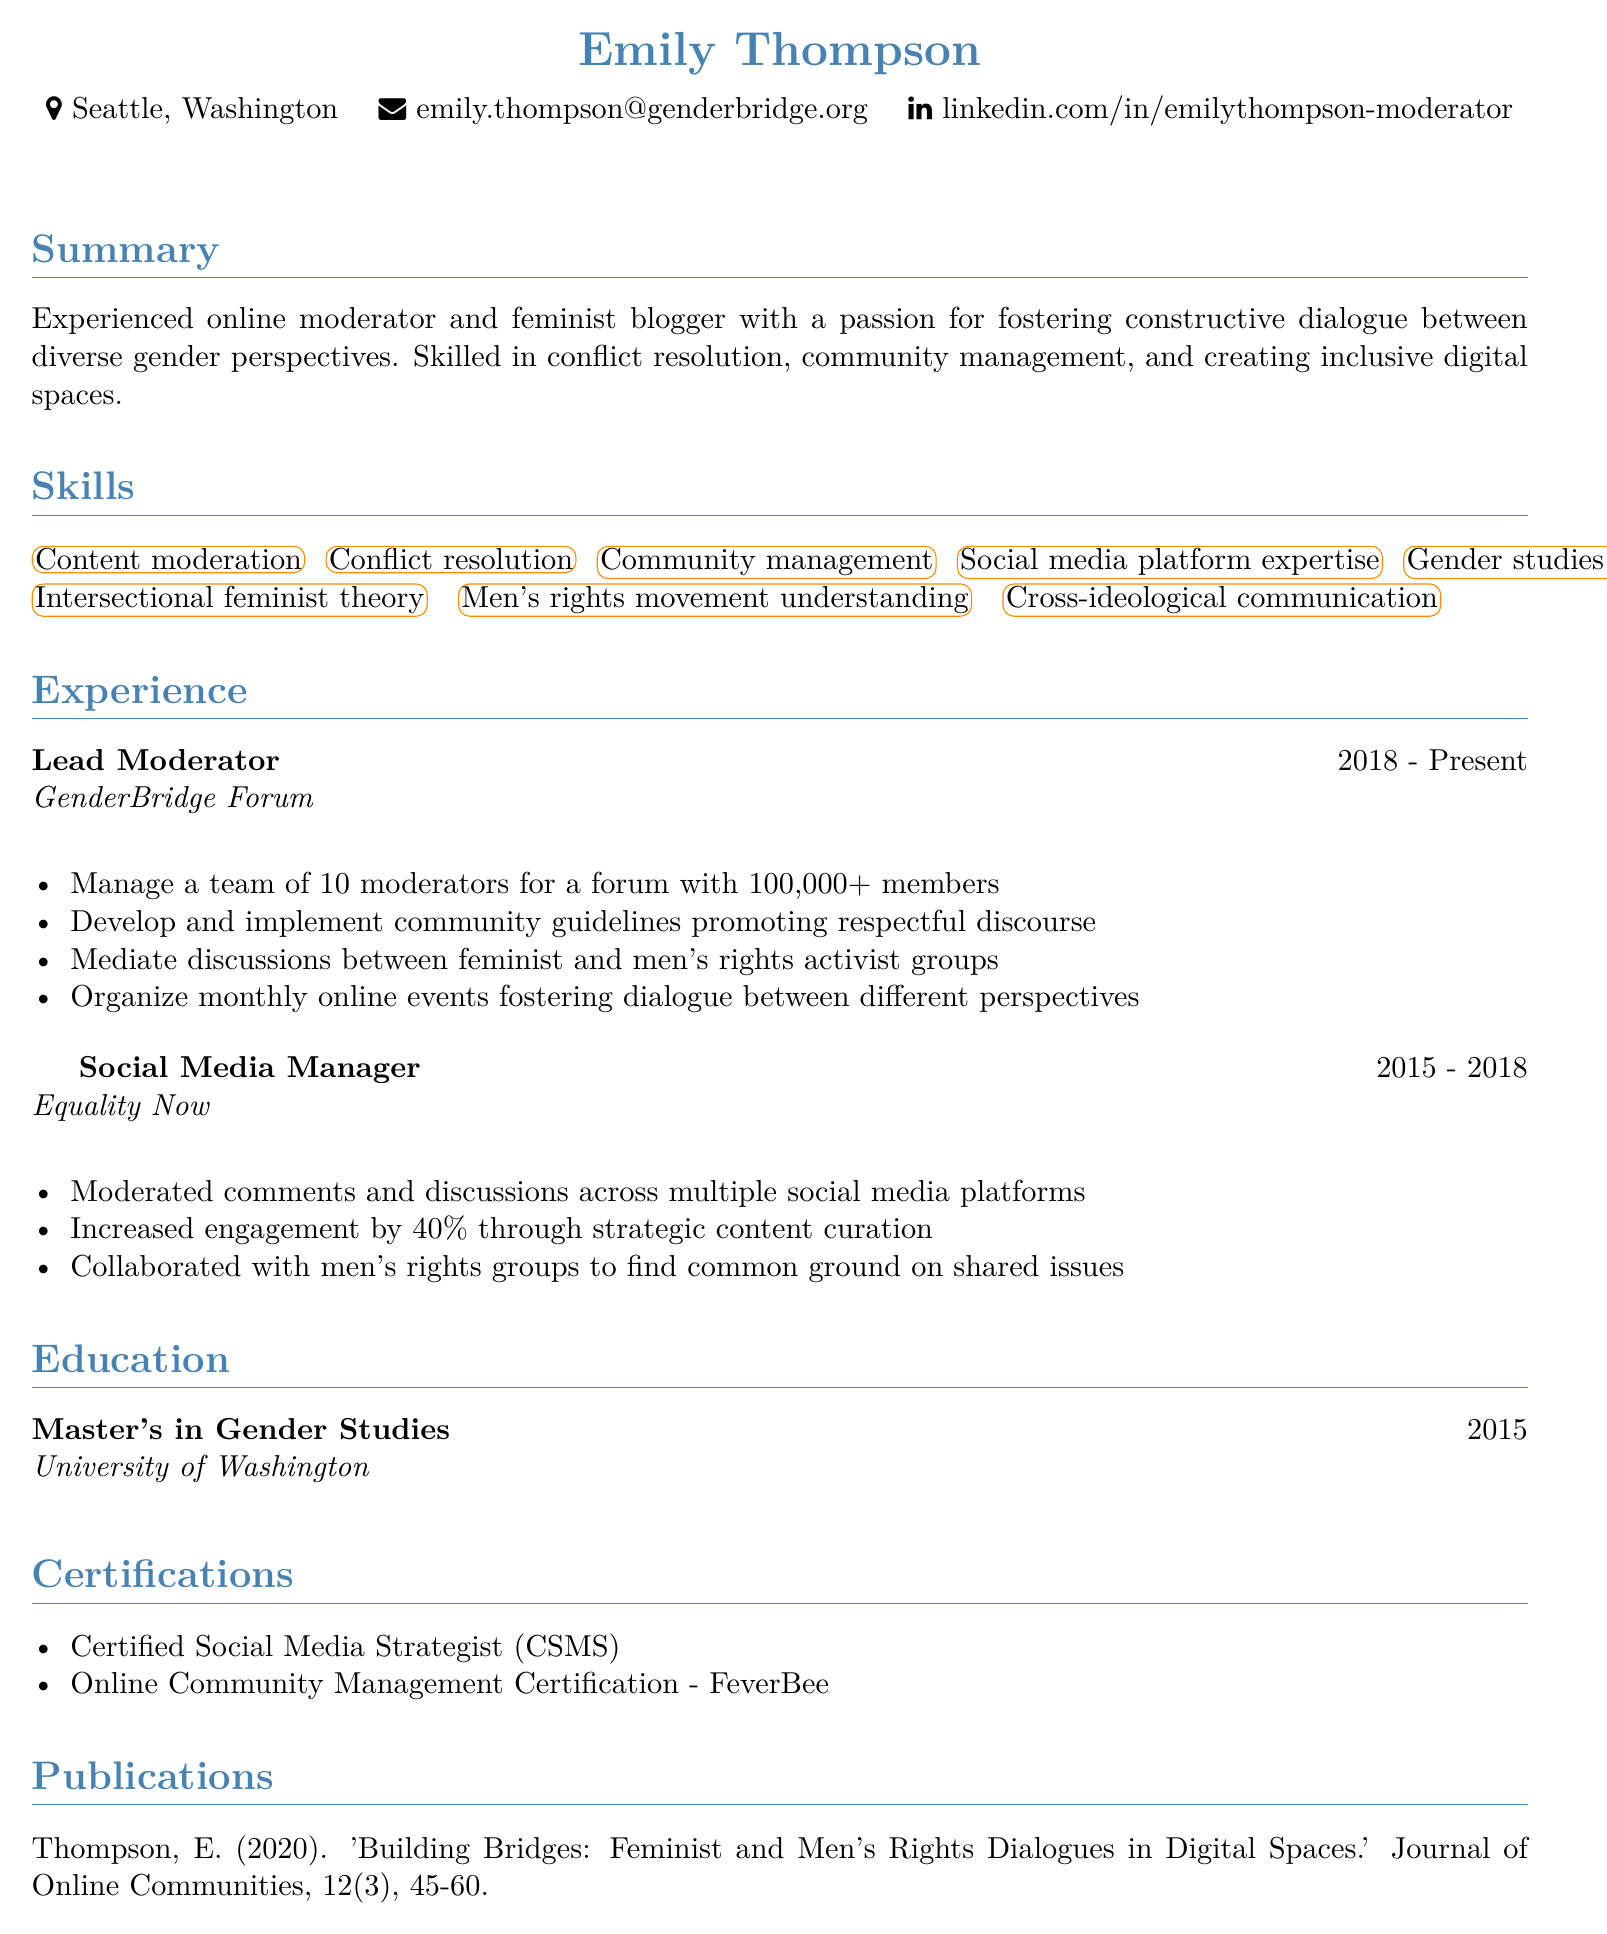What is the name of the individual? The name of the individual is found at the top of the document under the personal information section.
Answer: Emily Thompson How many moderators does Emily manage? This information is found in the experience section describing her responsibilities as Lead Moderator.
Answer: 10 What is Emily's current job title? The job title can be found in the experience section as the first entry.
Answer: Lead Moderator Which organization did Emily work for as a Social Media Manager? The organization is listed under her previous work experience in the document.
Answer: Equality Now In what year did Emily obtain her Master's degree? The year of her degree is provided in the education section of the document.
Answer: 2015 What is one of Emily's skills related to gender discussions? This information is found in the skills section of the document.
Answer: Content moderation What is the title of Emily's publication? The title is listed in the publications section at the end of the document.
Answer: Building Bridges: Feminist and Men's Rights Dialogues in Digital Spaces What kind of certification does Emily have related to social media strategy? This certification is listed in the certifications section, indicating her specialized training.
Answer: Certified Social Media Strategist 